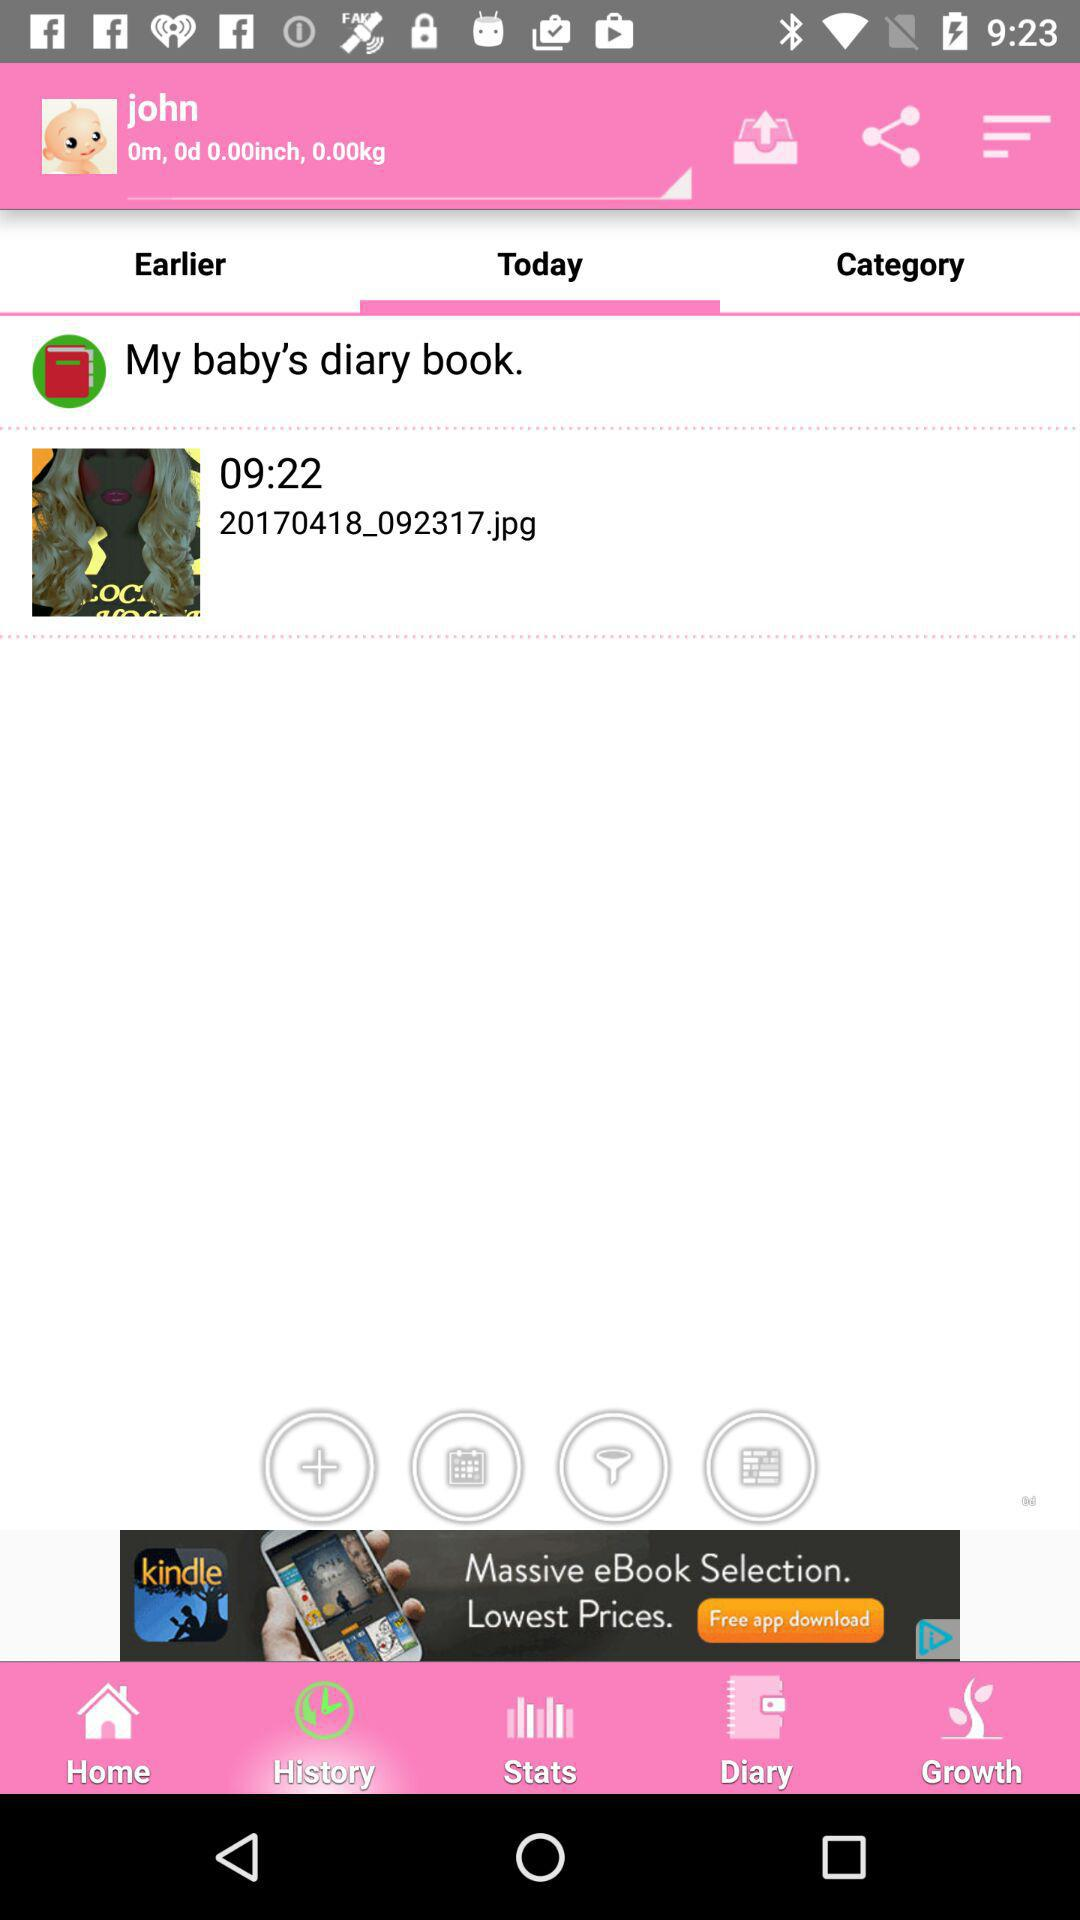How much height is mentioned? The height is 0 inches. 